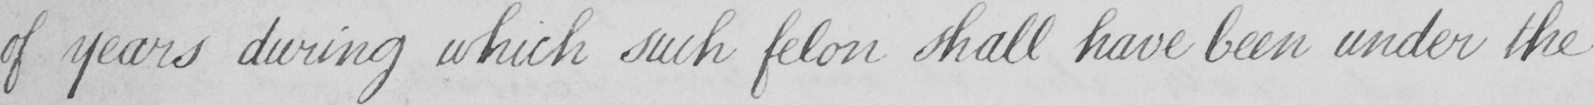What does this handwritten line say? of years during which such felon shall have been under the 